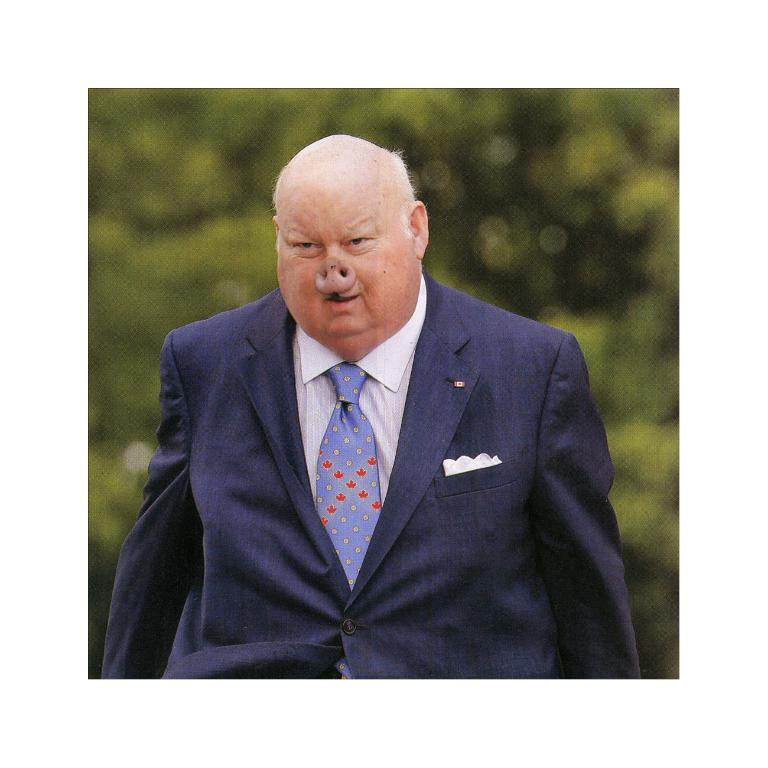Who or what is the main subject in the center of the image? There is a person in the center of the image. What can be seen in the background of the image? There is a tree visible in the background of the image. How many cobwebs can be seen hanging from the tree in the image? There is no mention of cobwebs in the image, so it is impossible to determine their presence or quantity. 